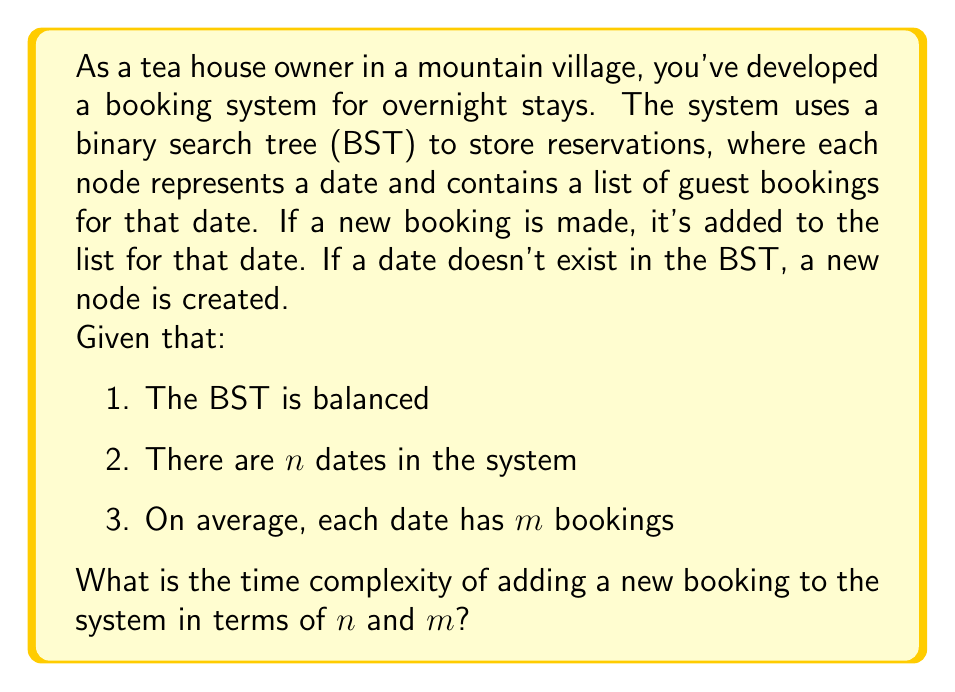Could you help me with this problem? To analyze the time complexity of adding a new booking, we need to consider two main operations:

1. Searching for the date in the BST
2. Adding the booking to the list for that date

Let's break it down step by step:

1. Searching the BST:
   - Since the BST is balanced, the height of the tree is $O(\log n)$
   - The time complexity of searching a balanced BST is $O(\log n)$

2. Adding the booking to the list:
   - If the date exists, we need to add the booking to the end of the list
   - Adding to the end of a list is typically an $O(1)$ operation
   - However, in the worst case (if we need to resize the list), it could be $O(m)$

3. Creating a new node (if the date doesn't exist):
   - This is an $O(1)$ operation

Therefore, the total time complexity is:

$$T(n, m) = O(\log n) + O(m)$$

The $O(\log n)$ term comes from searching the BST, and the $O(m)$ term accounts for the potential need to resize the list when adding a new booking.

We can't simplify this further because we don't know the relationship between $n$ and $m$. In practice, $m$ is likely to be much smaller than $n$, but without specific information, we need to keep both terms.
Answer: $O(\log n + m)$ 